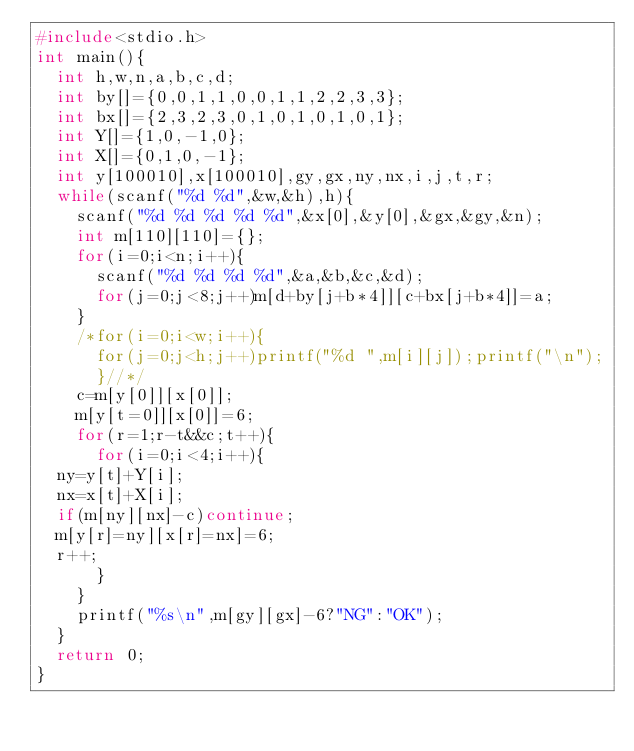Convert code to text. <code><loc_0><loc_0><loc_500><loc_500><_C_>#include<stdio.h>
int main(){
  int h,w,n,a,b,c,d;
  int by[]={0,0,1,1,0,0,1,1,2,2,3,3};
  int bx[]={2,3,2,3,0,1,0,1,0,1,0,1};
  int Y[]={1,0,-1,0};
  int X[]={0,1,0,-1};
  int y[100010],x[100010],gy,gx,ny,nx,i,j,t,r;
  while(scanf("%d %d",&w,&h),h){
    scanf("%d %d %d %d %d",&x[0],&y[0],&gx,&gy,&n);
    int m[110][110]={};
    for(i=0;i<n;i++){
      scanf("%d %d %d %d",&a,&b,&c,&d);
      for(j=0;j<8;j++)m[d+by[j+b*4]][c+bx[j+b*4]]=a;
    }
    /*for(i=0;i<w;i++){
      for(j=0;j<h;j++)printf("%d ",m[i][j]);printf("\n");
      }//*/
    c=m[y[0]][x[0]];
    m[y[t=0]][x[0]]=6;
    for(r=1;r-t&&c;t++){
      for(i=0;i<4;i++){
	ny=y[t]+Y[i];
	nx=x[t]+X[i];
	if(m[ny][nx]-c)continue;
	m[y[r]=ny][x[r]=nx]=6;
	r++;
      }
    }
    printf("%s\n",m[gy][gx]-6?"NG":"OK");
  }
  return 0;
}</code> 